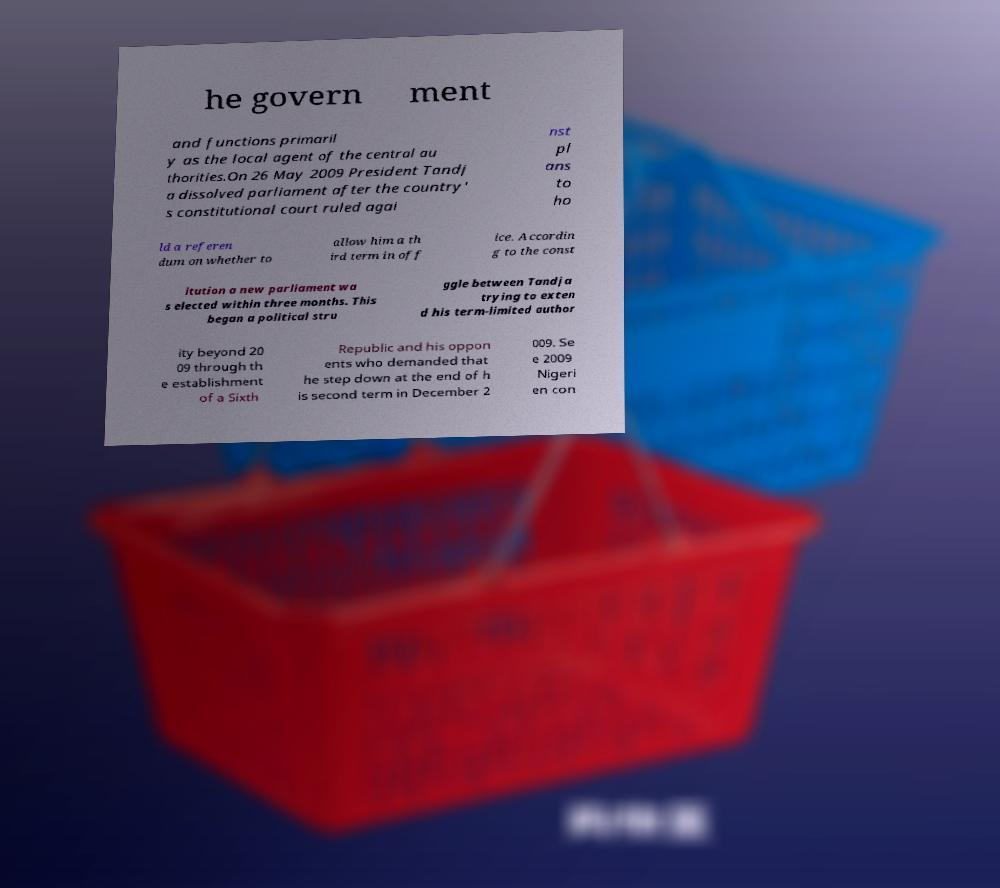For documentation purposes, I need the text within this image transcribed. Could you provide that? he govern ment and functions primaril y as the local agent of the central au thorities.On 26 May 2009 President Tandj a dissolved parliament after the country' s constitutional court ruled agai nst pl ans to ho ld a referen dum on whether to allow him a th ird term in off ice. Accordin g to the const itution a new parliament wa s elected within three months. This began a political stru ggle between Tandja trying to exten d his term-limited author ity beyond 20 09 through th e establishment of a Sixth Republic and his oppon ents who demanded that he step down at the end of h is second term in December 2 009. Se e 2009 Nigeri en con 